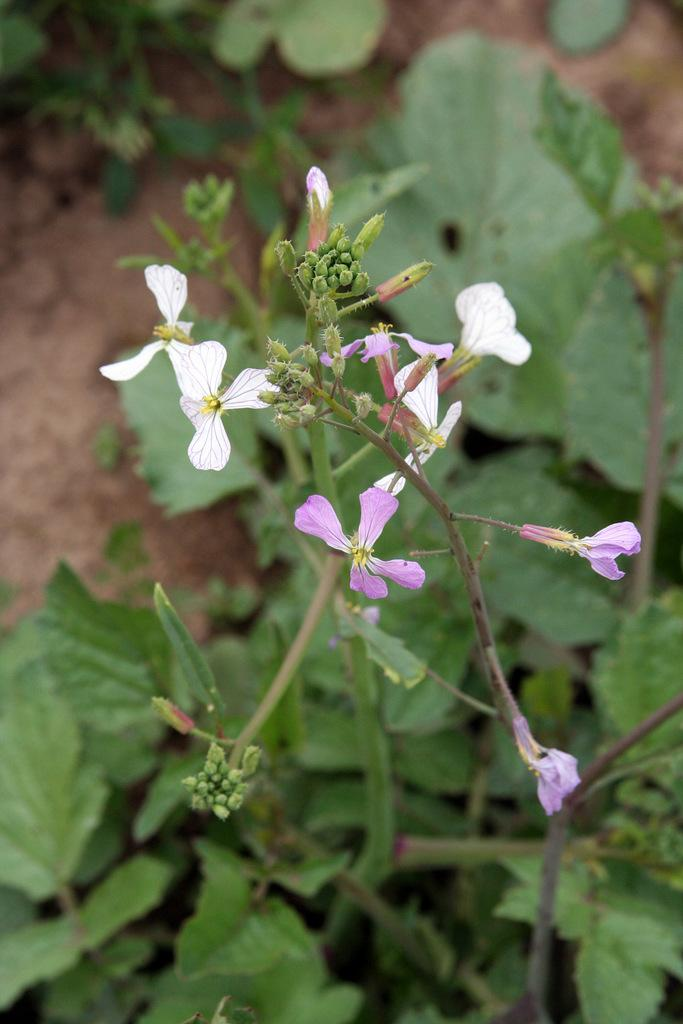What type of living organisms can be seen in the image? There are flowers and plants visible in the image. Can you describe the plants in the image? The plants in the image are not specified, but they are present alongside the flowers. What type of ray can be seen swimming in the image? There is no ray present in the image; it features flowers and plants. 